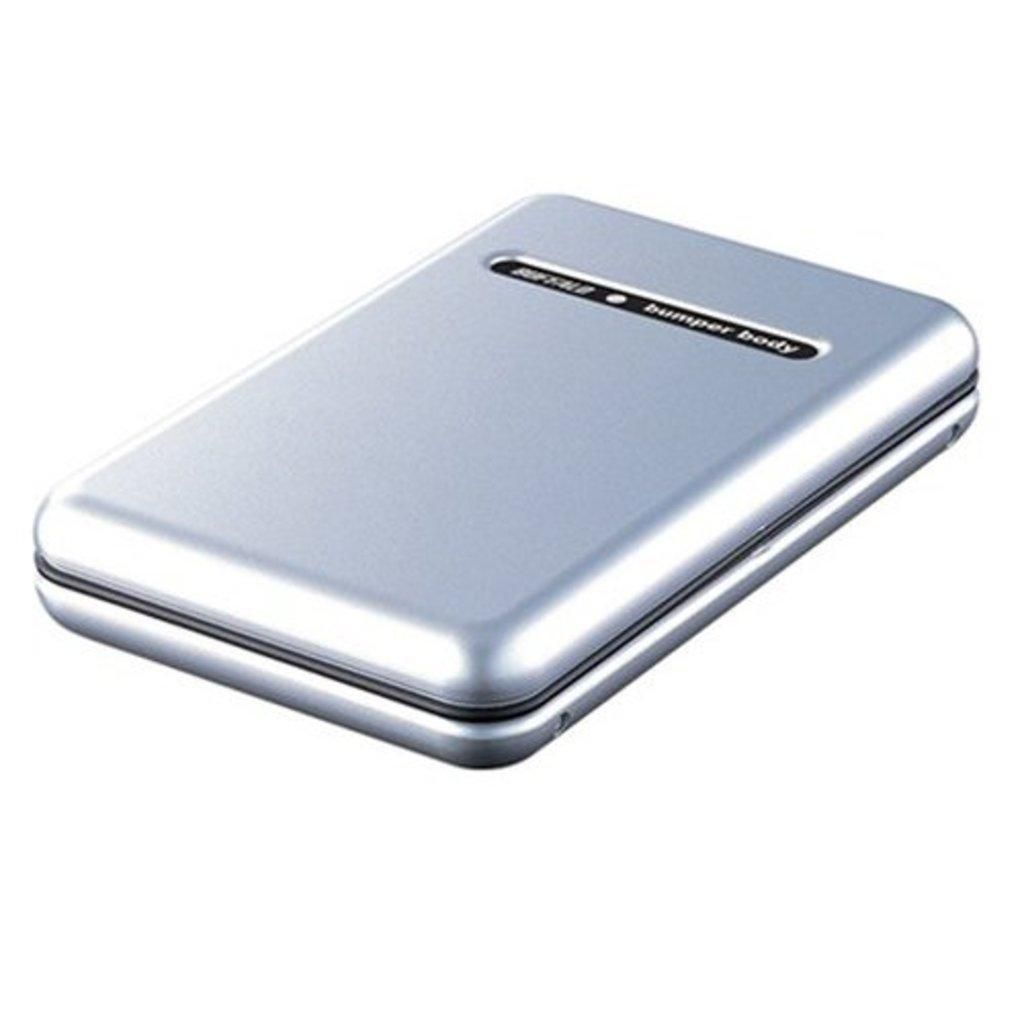<image>
Provide a brief description of the given image. A small device in a chrome color is labelled as Bumper Body. 